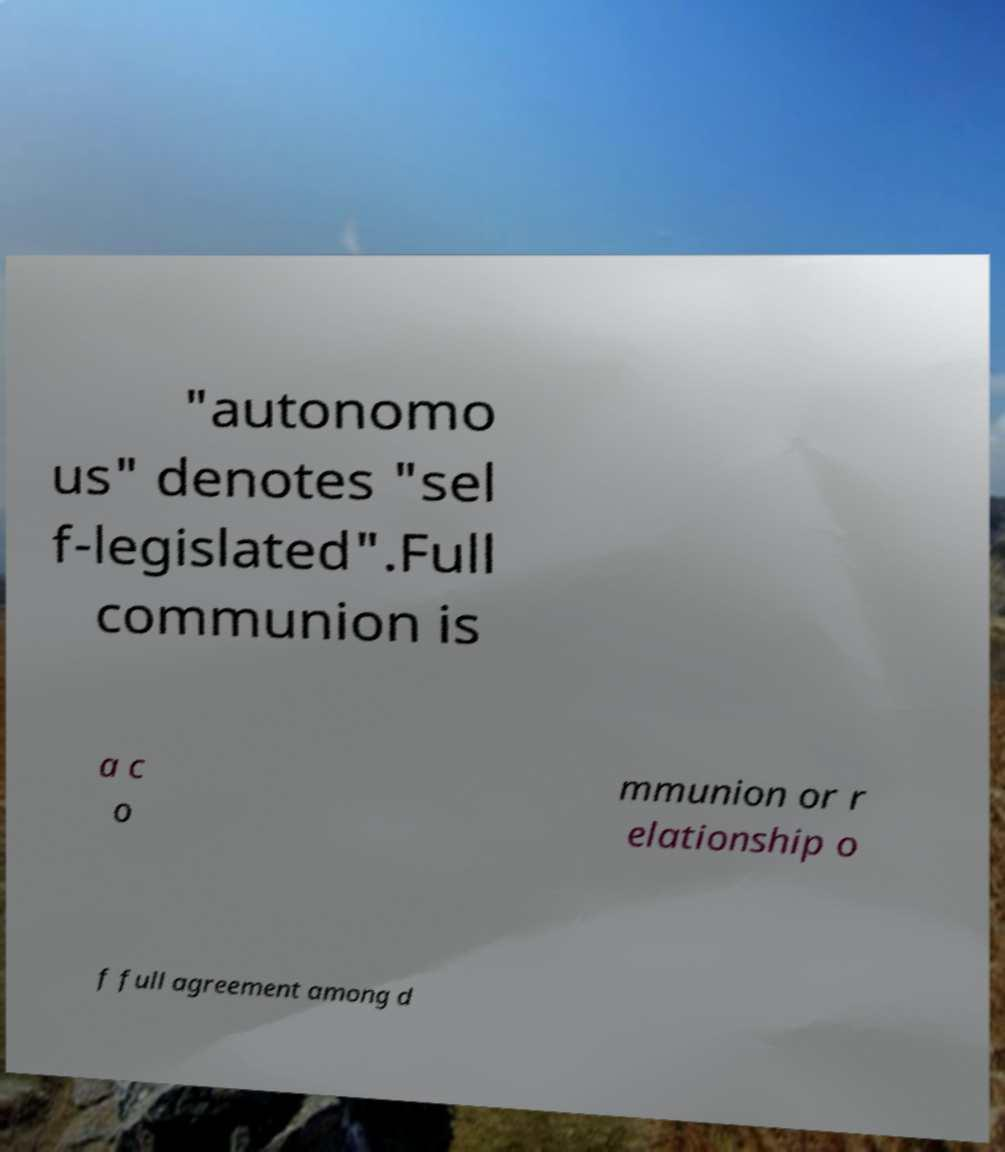Could you assist in decoding the text presented in this image and type it out clearly? "autonomo us" denotes "sel f-legislated".Full communion is a c o mmunion or r elationship o f full agreement among d 